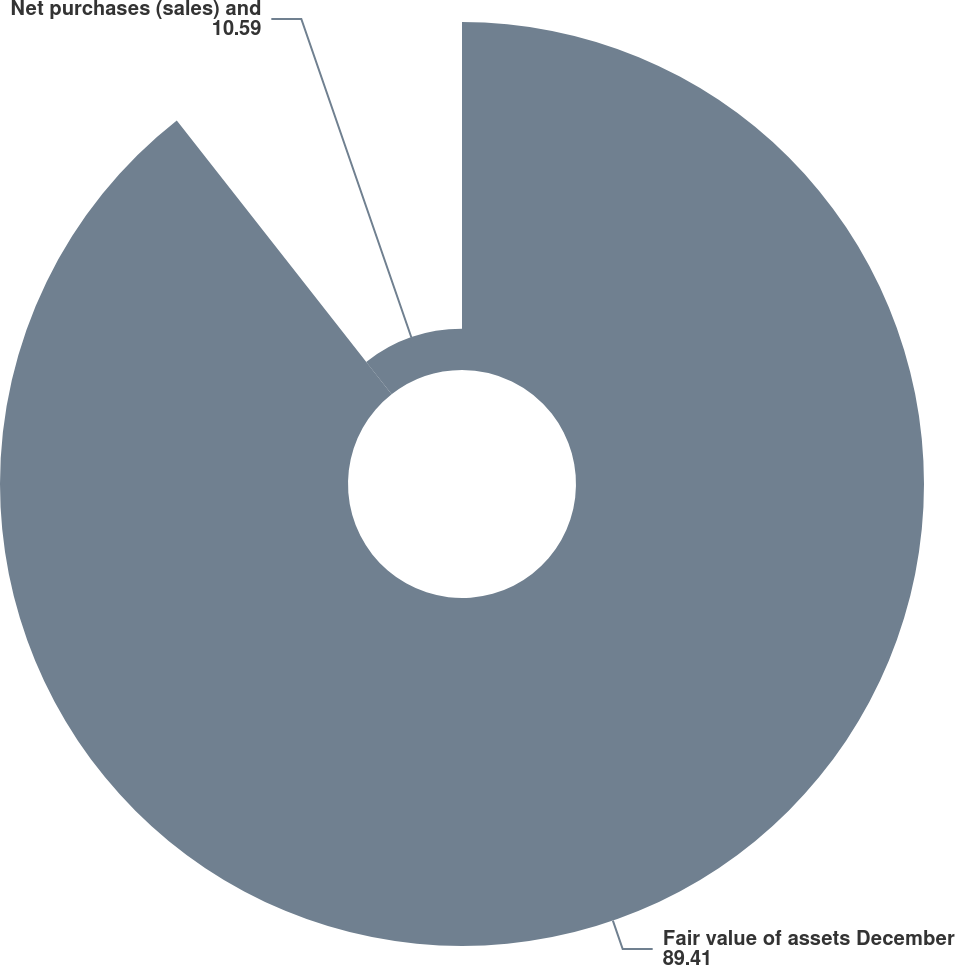Convert chart. <chart><loc_0><loc_0><loc_500><loc_500><pie_chart><fcel>Fair value of assets December<fcel>Net purchases (sales) and<nl><fcel>89.41%<fcel>10.59%<nl></chart> 